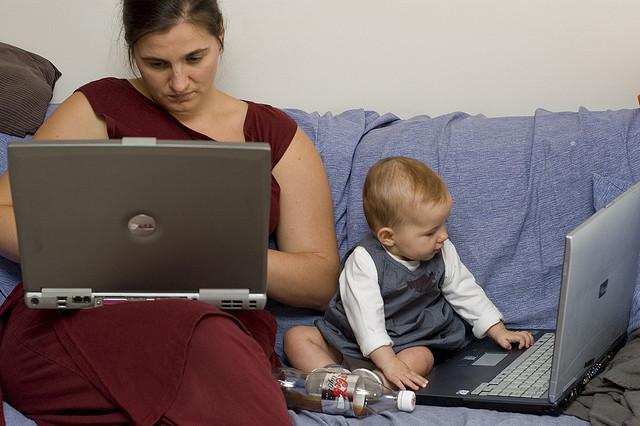Who was drinking from the coke bottle? woman 